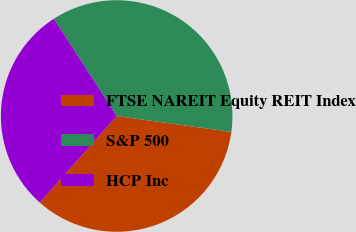Convert chart. <chart><loc_0><loc_0><loc_500><loc_500><pie_chart><fcel>FTSE NAREIT Equity REIT Index<fcel>S&P 500<fcel>HCP Inc<nl><fcel>34.36%<fcel>36.32%<fcel>29.32%<nl></chart> 